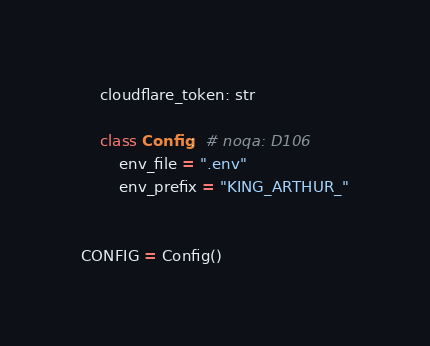<code> <loc_0><loc_0><loc_500><loc_500><_Python_>    cloudflare_token: str

    class Config:  # noqa: D106
        env_file = ".env"
        env_prefix = "KING_ARTHUR_"


CONFIG = Config()
</code> 